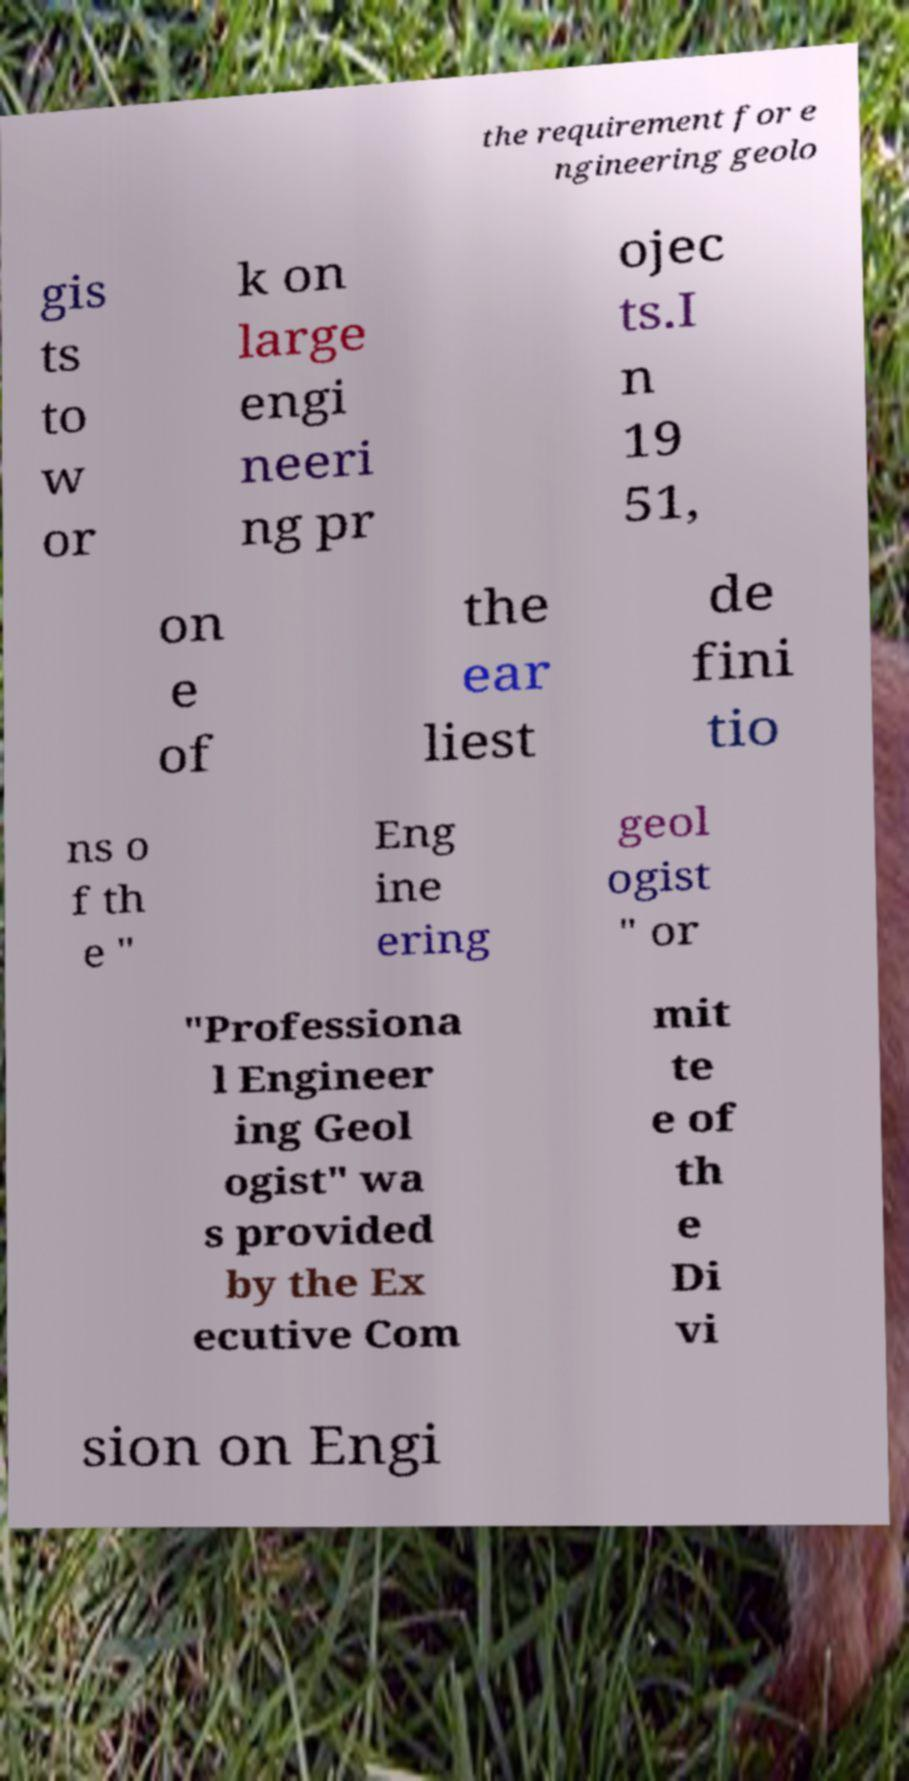Please read and relay the text visible in this image. What does it say? the requirement for e ngineering geolo gis ts to w or k on large engi neeri ng pr ojec ts.I n 19 51, on e of the ear liest de fini tio ns o f th e " Eng ine ering geol ogist " or "Professiona l Engineer ing Geol ogist" wa s provided by the Ex ecutive Com mit te e of th e Di vi sion on Engi 